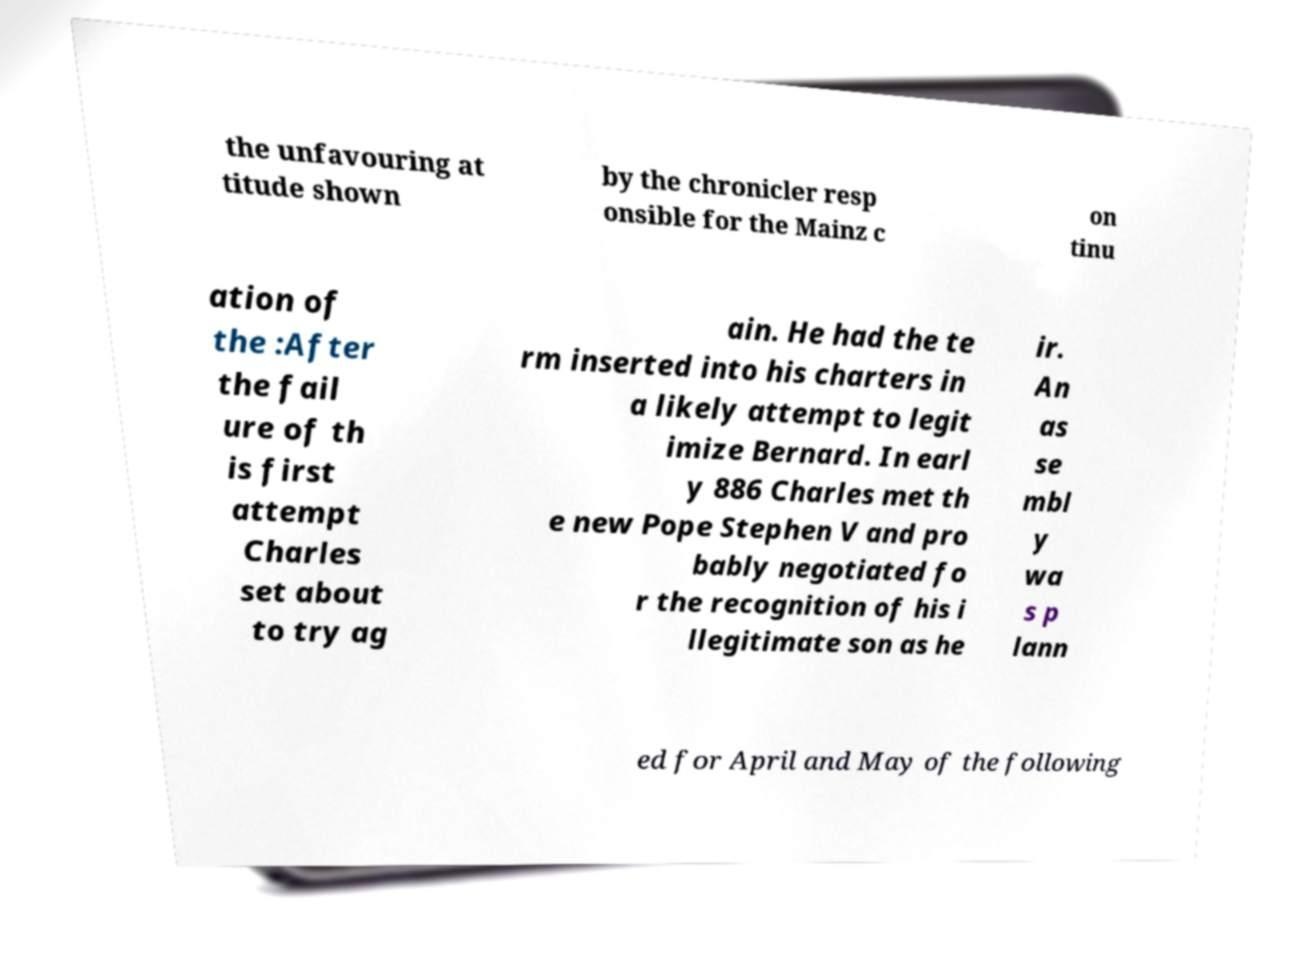Could you assist in decoding the text presented in this image and type it out clearly? the unfavouring at titude shown by the chronicler resp onsible for the Mainz c on tinu ation of the :After the fail ure of th is first attempt Charles set about to try ag ain. He had the te rm inserted into his charters in a likely attempt to legit imize Bernard. In earl y 886 Charles met th e new Pope Stephen V and pro bably negotiated fo r the recognition of his i llegitimate son as he ir. An as se mbl y wa s p lann ed for April and May of the following 